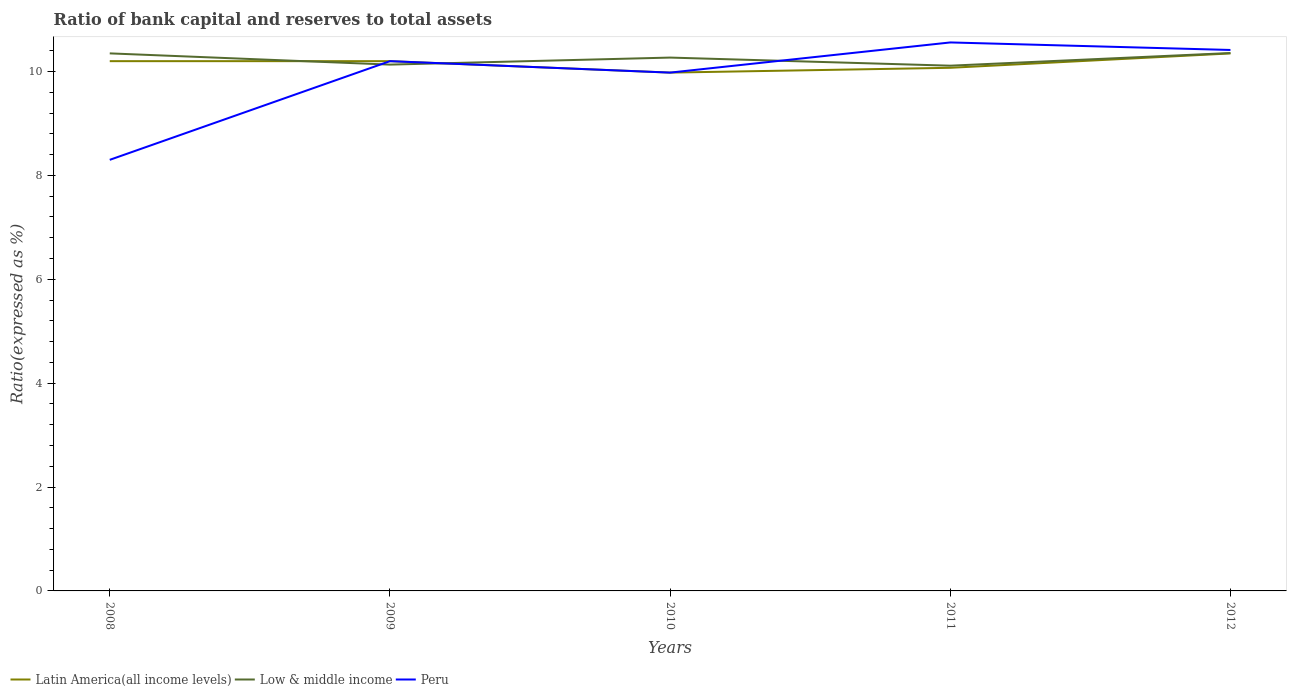How many different coloured lines are there?
Ensure brevity in your answer.  3. Across all years, what is the maximum ratio of bank capital and reserves to total assets in Low & middle income?
Your response must be concise. 10.11. What is the total ratio of bank capital and reserves to total assets in Low & middle income in the graph?
Your answer should be very brief. 0.08. What is the difference between the highest and the second highest ratio of bank capital and reserves to total assets in Latin America(all income levels)?
Provide a short and direct response. 0.37. What is the difference between the highest and the lowest ratio of bank capital and reserves to total assets in Low & middle income?
Keep it short and to the point. 3. How many lines are there?
Keep it short and to the point. 3. How many years are there in the graph?
Give a very brief answer. 5. What is the difference between two consecutive major ticks on the Y-axis?
Make the answer very short. 2. Are the values on the major ticks of Y-axis written in scientific E-notation?
Offer a terse response. No. Does the graph contain any zero values?
Offer a terse response. No. Where does the legend appear in the graph?
Make the answer very short. Bottom left. How are the legend labels stacked?
Your answer should be very brief. Horizontal. What is the title of the graph?
Make the answer very short. Ratio of bank capital and reserves to total assets. Does "High income" appear as one of the legend labels in the graph?
Your response must be concise. No. What is the label or title of the X-axis?
Offer a terse response. Years. What is the label or title of the Y-axis?
Provide a succinct answer. Ratio(expressed as %). What is the Ratio(expressed as %) of Latin America(all income levels) in 2008?
Your answer should be compact. 10.2. What is the Ratio(expressed as %) of Low & middle income in 2008?
Offer a terse response. 10.35. What is the Ratio(expressed as %) of Peru in 2008?
Offer a very short reply. 8.3. What is the Ratio(expressed as %) of Latin America(all income levels) in 2009?
Your response must be concise. 10.2. What is the Ratio(expressed as %) of Low & middle income in 2009?
Provide a succinct answer. 10.13. What is the Ratio(expressed as %) in Peru in 2009?
Your answer should be very brief. 10.2. What is the Ratio(expressed as %) in Latin America(all income levels) in 2010?
Your answer should be compact. 9.98. What is the Ratio(expressed as %) in Low & middle income in 2010?
Offer a very short reply. 10.27. What is the Ratio(expressed as %) in Peru in 2010?
Provide a short and direct response. 9.98. What is the Ratio(expressed as %) in Latin America(all income levels) in 2011?
Provide a succinct answer. 10.07. What is the Ratio(expressed as %) of Low & middle income in 2011?
Give a very brief answer. 10.11. What is the Ratio(expressed as %) in Peru in 2011?
Make the answer very short. 10.56. What is the Ratio(expressed as %) in Latin America(all income levels) in 2012?
Make the answer very short. 10.35. What is the Ratio(expressed as %) in Low & middle income in 2012?
Offer a terse response. 10.36. What is the Ratio(expressed as %) of Peru in 2012?
Your answer should be very brief. 10.42. Across all years, what is the maximum Ratio(expressed as %) of Latin America(all income levels)?
Your response must be concise. 10.35. Across all years, what is the maximum Ratio(expressed as %) of Low & middle income?
Your answer should be very brief. 10.36. Across all years, what is the maximum Ratio(expressed as %) in Peru?
Your response must be concise. 10.56. Across all years, what is the minimum Ratio(expressed as %) in Latin America(all income levels)?
Offer a terse response. 9.98. Across all years, what is the minimum Ratio(expressed as %) in Low & middle income?
Provide a short and direct response. 10.11. Across all years, what is the minimum Ratio(expressed as %) in Peru?
Offer a terse response. 8.3. What is the total Ratio(expressed as %) in Latin America(all income levels) in the graph?
Your response must be concise. 50.8. What is the total Ratio(expressed as %) of Low & middle income in the graph?
Your answer should be compact. 51.22. What is the total Ratio(expressed as %) of Peru in the graph?
Offer a terse response. 49.46. What is the difference between the Ratio(expressed as %) in Low & middle income in 2008 and that in 2009?
Ensure brevity in your answer.  0.22. What is the difference between the Ratio(expressed as %) of Peru in 2008 and that in 2009?
Give a very brief answer. -1.9. What is the difference between the Ratio(expressed as %) of Latin America(all income levels) in 2008 and that in 2010?
Provide a succinct answer. 0.22. What is the difference between the Ratio(expressed as %) of Low & middle income in 2008 and that in 2010?
Ensure brevity in your answer.  0.08. What is the difference between the Ratio(expressed as %) in Peru in 2008 and that in 2010?
Make the answer very short. -1.68. What is the difference between the Ratio(expressed as %) in Latin America(all income levels) in 2008 and that in 2011?
Ensure brevity in your answer.  0.13. What is the difference between the Ratio(expressed as %) in Low & middle income in 2008 and that in 2011?
Your answer should be very brief. 0.24. What is the difference between the Ratio(expressed as %) of Peru in 2008 and that in 2011?
Keep it short and to the point. -2.26. What is the difference between the Ratio(expressed as %) in Latin America(all income levels) in 2008 and that in 2012?
Keep it short and to the point. -0.15. What is the difference between the Ratio(expressed as %) in Low & middle income in 2008 and that in 2012?
Your answer should be compact. -0.01. What is the difference between the Ratio(expressed as %) of Peru in 2008 and that in 2012?
Offer a terse response. -2.12. What is the difference between the Ratio(expressed as %) of Latin America(all income levels) in 2009 and that in 2010?
Your answer should be very brief. 0.22. What is the difference between the Ratio(expressed as %) in Low & middle income in 2009 and that in 2010?
Offer a very short reply. -0.14. What is the difference between the Ratio(expressed as %) in Peru in 2009 and that in 2010?
Your answer should be compact. 0.22. What is the difference between the Ratio(expressed as %) in Latin America(all income levels) in 2009 and that in 2011?
Your answer should be very brief. 0.13. What is the difference between the Ratio(expressed as %) in Low & middle income in 2009 and that in 2011?
Provide a short and direct response. 0.02. What is the difference between the Ratio(expressed as %) of Peru in 2009 and that in 2011?
Your answer should be very brief. -0.36. What is the difference between the Ratio(expressed as %) in Latin America(all income levels) in 2009 and that in 2012?
Your answer should be compact. -0.15. What is the difference between the Ratio(expressed as %) of Low & middle income in 2009 and that in 2012?
Provide a succinct answer. -0.22. What is the difference between the Ratio(expressed as %) in Peru in 2009 and that in 2012?
Offer a very short reply. -0.22. What is the difference between the Ratio(expressed as %) in Latin America(all income levels) in 2010 and that in 2011?
Your answer should be very brief. -0.09. What is the difference between the Ratio(expressed as %) of Low & middle income in 2010 and that in 2011?
Give a very brief answer. 0.16. What is the difference between the Ratio(expressed as %) of Peru in 2010 and that in 2011?
Provide a succinct answer. -0.58. What is the difference between the Ratio(expressed as %) of Latin America(all income levels) in 2010 and that in 2012?
Give a very brief answer. -0.37. What is the difference between the Ratio(expressed as %) of Low & middle income in 2010 and that in 2012?
Make the answer very short. -0.09. What is the difference between the Ratio(expressed as %) in Peru in 2010 and that in 2012?
Provide a succinct answer. -0.44. What is the difference between the Ratio(expressed as %) of Latin America(all income levels) in 2011 and that in 2012?
Keep it short and to the point. -0.28. What is the difference between the Ratio(expressed as %) of Low & middle income in 2011 and that in 2012?
Provide a short and direct response. -0.24. What is the difference between the Ratio(expressed as %) of Peru in 2011 and that in 2012?
Provide a short and direct response. 0.14. What is the difference between the Ratio(expressed as %) in Latin America(all income levels) in 2008 and the Ratio(expressed as %) in Low & middle income in 2009?
Make the answer very short. 0.07. What is the difference between the Ratio(expressed as %) of Latin America(all income levels) in 2008 and the Ratio(expressed as %) of Peru in 2009?
Give a very brief answer. 0. What is the difference between the Ratio(expressed as %) in Latin America(all income levels) in 2008 and the Ratio(expressed as %) in Low & middle income in 2010?
Ensure brevity in your answer.  -0.07. What is the difference between the Ratio(expressed as %) of Latin America(all income levels) in 2008 and the Ratio(expressed as %) of Peru in 2010?
Keep it short and to the point. 0.22. What is the difference between the Ratio(expressed as %) in Low & middle income in 2008 and the Ratio(expressed as %) in Peru in 2010?
Your answer should be very brief. 0.37. What is the difference between the Ratio(expressed as %) of Latin America(all income levels) in 2008 and the Ratio(expressed as %) of Low & middle income in 2011?
Make the answer very short. 0.09. What is the difference between the Ratio(expressed as %) of Latin America(all income levels) in 2008 and the Ratio(expressed as %) of Peru in 2011?
Offer a very short reply. -0.36. What is the difference between the Ratio(expressed as %) of Low & middle income in 2008 and the Ratio(expressed as %) of Peru in 2011?
Provide a short and direct response. -0.21. What is the difference between the Ratio(expressed as %) of Latin America(all income levels) in 2008 and the Ratio(expressed as %) of Low & middle income in 2012?
Your answer should be compact. -0.16. What is the difference between the Ratio(expressed as %) in Latin America(all income levels) in 2008 and the Ratio(expressed as %) in Peru in 2012?
Ensure brevity in your answer.  -0.22. What is the difference between the Ratio(expressed as %) of Low & middle income in 2008 and the Ratio(expressed as %) of Peru in 2012?
Your response must be concise. -0.07. What is the difference between the Ratio(expressed as %) in Latin America(all income levels) in 2009 and the Ratio(expressed as %) in Low & middle income in 2010?
Offer a very short reply. -0.07. What is the difference between the Ratio(expressed as %) of Latin America(all income levels) in 2009 and the Ratio(expressed as %) of Peru in 2010?
Make the answer very short. 0.22. What is the difference between the Ratio(expressed as %) in Low & middle income in 2009 and the Ratio(expressed as %) in Peru in 2010?
Provide a short and direct response. 0.15. What is the difference between the Ratio(expressed as %) of Latin America(all income levels) in 2009 and the Ratio(expressed as %) of Low & middle income in 2011?
Your answer should be compact. 0.09. What is the difference between the Ratio(expressed as %) of Latin America(all income levels) in 2009 and the Ratio(expressed as %) of Peru in 2011?
Provide a short and direct response. -0.36. What is the difference between the Ratio(expressed as %) of Low & middle income in 2009 and the Ratio(expressed as %) of Peru in 2011?
Provide a short and direct response. -0.43. What is the difference between the Ratio(expressed as %) of Latin America(all income levels) in 2009 and the Ratio(expressed as %) of Low & middle income in 2012?
Your answer should be very brief. -0.16. What is the difference between the Ratio(expressed as %) of Latin America(all income levels) in 2009 and the Ratio(expressed as %) of Peru in 2012?
Provide a succinct answer. -0.22. What is the difference between the Ratio(expressed as %) in Low & middle income in 2009 and the Ratio(expressed as %) in Peru in 2012?
Your answer should be very brief. -0.28. What is the difference between the Ratio(expressed as %) in Latin America(all income levels) in 2010 and the Ratio(expressed as %) in Low & middle income in 2011?
Your answer should be compact. -0.13. What is the difference between the Ratio(expressed as %) of Latin America(all income levels) in 2010 and the Ratio(expressed as %) of Peru in 2011?
Make the answer very short. -0.58. What is the difference between the Ratio(expressed as %) of Low & middle income in 2010 and the Ratio(expressed as %) of Peru in 2011?
Your response must be concise. -0.29. What is the difference between the Ratio(expressed as %) of Latin America(all income levels) in 2010 and the Ratio(expressed as %) of Low & middle income in 2012?
Your answer should be compact. -0.38. What is the difference between the Ratio(expressed as %) of Latin America(all income levels) in 2010 and the Ratio(expressed as %) of Peru in 2012?
Your answer should be very brief. -0.44. What is the difference between the Ratio(expressed as %) of Low & middle income in 2010 and the Ratio(expressed as %) of Peru in 2012?
Your answer should be very brief. -0.15. What is the difference between the Ratio(expressed as %) of Latin America(all income levels) in 2011 and the Ratio(expressed as %) of Low & middle income in 2012?
Offer a very short reply. -0.28. What is the difference between the Ratio(expressed as %) of Latin America(all income levels) in 2011 and the Ratio(expressed as %) of Peru in 2012?
Your answer should be compact. -0.34. What is the difference between the Ratio(expressed as %) in Low & middle income in 2011 and the Ratio(expressed as %) in Peru in 2012?
Ensure brevity in your answer.  -0.3. What is the average Ratio(expressed as %) in Latin America(all income levels) per year?
Offer a terse response. 10.16. What is the average Ratio(expressed as %) of Low & middle income per year?
Make the answer very short. 10.24. What is the average Ratio(expressed as %) in Peru per year?
Your response must be concise. 9.89. In the year 2008, what is the difference between the Ratio(expressed as %) in Latin America(all income levels) and Ratio(expressed as %) in Peru?
Ensure brevity in your answer.  1.9. In the year 2008, what is the difference between the Ratio(expressed as %) in Low & middle income and Ratio(expressed as %) in Peru?
Your answer should be compact. 2.05. In the year 2009, what is the difference between the Ratio(expressed as %) of Latin America(all income levels) and Ratio(expressed as %) of Low & middle income?
Keep it short and to the point. 0.07. In the year 2009, what is the difference between the Ratio(expressed as %) of Low & middle income and Ratio(expressed as %) of Peru?
Provide a succinct answer. -0.07. In the year 2010, what is the difference between the Ratio(expressed as %) of Latin America(all income levels) and Ratio(expressed as %) of Low & middle income?
Offer a terse response. -0.29. In the year 2010, what is the difference between the Ratio(expressed as %) of Latin America(all income levels) and Ratio(expressed as %) of Peru?
Make the answer very short. 0. In the year 2010, what is the difference between the Ratio(expressed as %) in Low & middle income and Ratio(expressed as %) in Peru?
Make the answer very short. 0.29. In the year 2011, what is the difference between the Ratio(expressed as %) in Latin America(all income levels) and Ratio(expressed as %) in Low & middle income?
Your response must be concise. -0.04. In the year 2011, what is the difference between the Ratio(expressed as %) of Latin America(all income levels) and Ratio(expressed as %) of Peru?
Keep it short and to the point. -0.49. In the year 2011, what is the difference between the Ratio(expressed as %) of Low & middle income and Ratio(expressed as %) of Peru?
Make the answer very short. -0.45. In the year 2012, what is the difference between the Ratio(expressed as %) in Latin America(all income levels) and Ratio(expressed as %) in Low & middle income?
Make the answer very short. -0.01. In the year 2012, what is the difference between the Ratio(expressed as %) of Latin America(all income levels) and Ratio(expressed as %) of Peru?
Your answer should be very brief. -0.07. In the year 2012, what is the difference between the Ratio(expressed as %) in Low & middle income and Ratio(expressed as %) in Peru?
Offer a very short reply. -0.06. What is the ratio of the Ratio(expressed as %) of Low & middle income in 2008 to that in 2009?
Your response must be concise. 1.02. What is the ratio of the Ratio(expressed as %) in Peru in 2008 to that in 2009?
Provide a succinct answer. 0.81. What is the ratio of the Ratio(expressed as %) in Latin America(all income levels) in 2008 to that in 2010?
Your response must be concise. 1.02. What is the ratio of the Ratio(expressed as %) of Low & middle income in 2008 to that in 2010?
Offer a very short reply. 1.01. What is the ratio of the Ratio(expressed as %) in Peru in 2008 to that in 2010?
Provide a short and direct response. 0.83. What is the ratio of the Ratio(expressed as %) in Latin America(all income levels) in 2008 to that in 2011?
Make the answer very short. 1.01. What is the ratio of the Ratio(expressed as %) in Low & middle income in 2008 to that in 2011?
Your answer should be compact. 1.02. What is the ratio of the Ratio(expressed as %) in Peru in 2008 to that in 2011?
Your answer should be compact. 0.79. What is the ratio of the Ratio(expressed as %) in Latin America(all income levels) in 2008 to that in 2012?
Give a very brief answer. 0.99. What is the ratio of the Ratio(expressed as %) in Peru in 2008 to that in 2012?
Make the answer very short. 0.8. What is the ratio of the Ratio(expressed as %) in Latin America(all income levels) in 2009 to that in 2010?
Give a very brief answer. 1.02. What is the ratio of the Ratio(expressed as %) in Peru in 2009 to that in 2010?
Give a very brief answer. 1.02. What is the ratio of the Ratio(expressed as %) of Latin America(all income levels) in 2009 to that in 2011?
Provide a short and direct response. 1.01. What is the ratio of the Ratio(expressed as %) of Low & middle income in 2009 to that in 2011?
Provide a short and direct response. 1. What is the ratio of the Ratio(expressed as %) in Peru in 2009 to that in 2011?
Provide a succinct answer. 0.97. What is the ratio of the Ratio(expressed as %) in Latin America(all income levels) in 2009 to that in 2012?
Give a very brief answer. 0.99. What is the ratio of the Ratio(expressed as %) of Low & middle income in 2009 to that in 2012?
Provide a short and direct response. 0.98. What is the ratio of the Ratio(expressed as %) of Peru in 2009 to that in 2012?
Your answer should be compact. 0.98. What is the ratio of the Ratio(expressed as %) of Latin America(all income levels) in 2010 to that in 2011?
Keep it short and to the point. 0.99. What is the ratio of the Ratio(expressed as %) of Low & middle income in 2010 to that in 2011?
Your answer should be very brief. 1.02. What is the ratio of the Ratio(expressed as %) in Peru in 2010 to that in 2011?
Ensure brevity in your answer.  0.94. What is the ratio of the Ratio(expressed as %) of Low & middle income in 2010 to that in 2012?
Make the answer very short. 0.99. What is the ratio of the Ratio(expressed as %) in Peru in 2010 to that in 2012?
Offer a very short reply. 0.96. What is the ratio of the Ratio(expressed as %) in Latin America(all income levels) in 2011 to that in 2012?
Your response must be concise. 0.97. What is the ratio of the Ratio(expressed as %) of Low & middle income in 2011 to that in 2012?
Make the answer very short. 0.98. What is the ratio of the Ratio(expressed as %) of Peru in 2011 to that in 2012?
Ensure brevity in your answer.  1.01. What is the difference between the highest and the second highest Ratio(expressed as %) in Latin America(all income levels)?
Provide a succinct answer. 0.15. What is the difference between the highest and the second highest Ratio(expressed as %) of Low & middle income?
Give a very brief answer. 0.01. What is the difference between the highest and the second highest Ratio(expressed as %) in Peru?
Give a very brief answer. 0.14. What is the difference between the highest and the lowest Ratio(expressed as %) in Latin America(all income levels)?
Give a very brief answer. 0.37. What is the difference between the highest and the lowest Ratio(expressed as %) of Low & middle income?
Your answer should be very brief. 0.24. What is the difference between the highest and the lowest Ratio(expressed as %) of Peru?
Your answer should be compact. 2.26. 